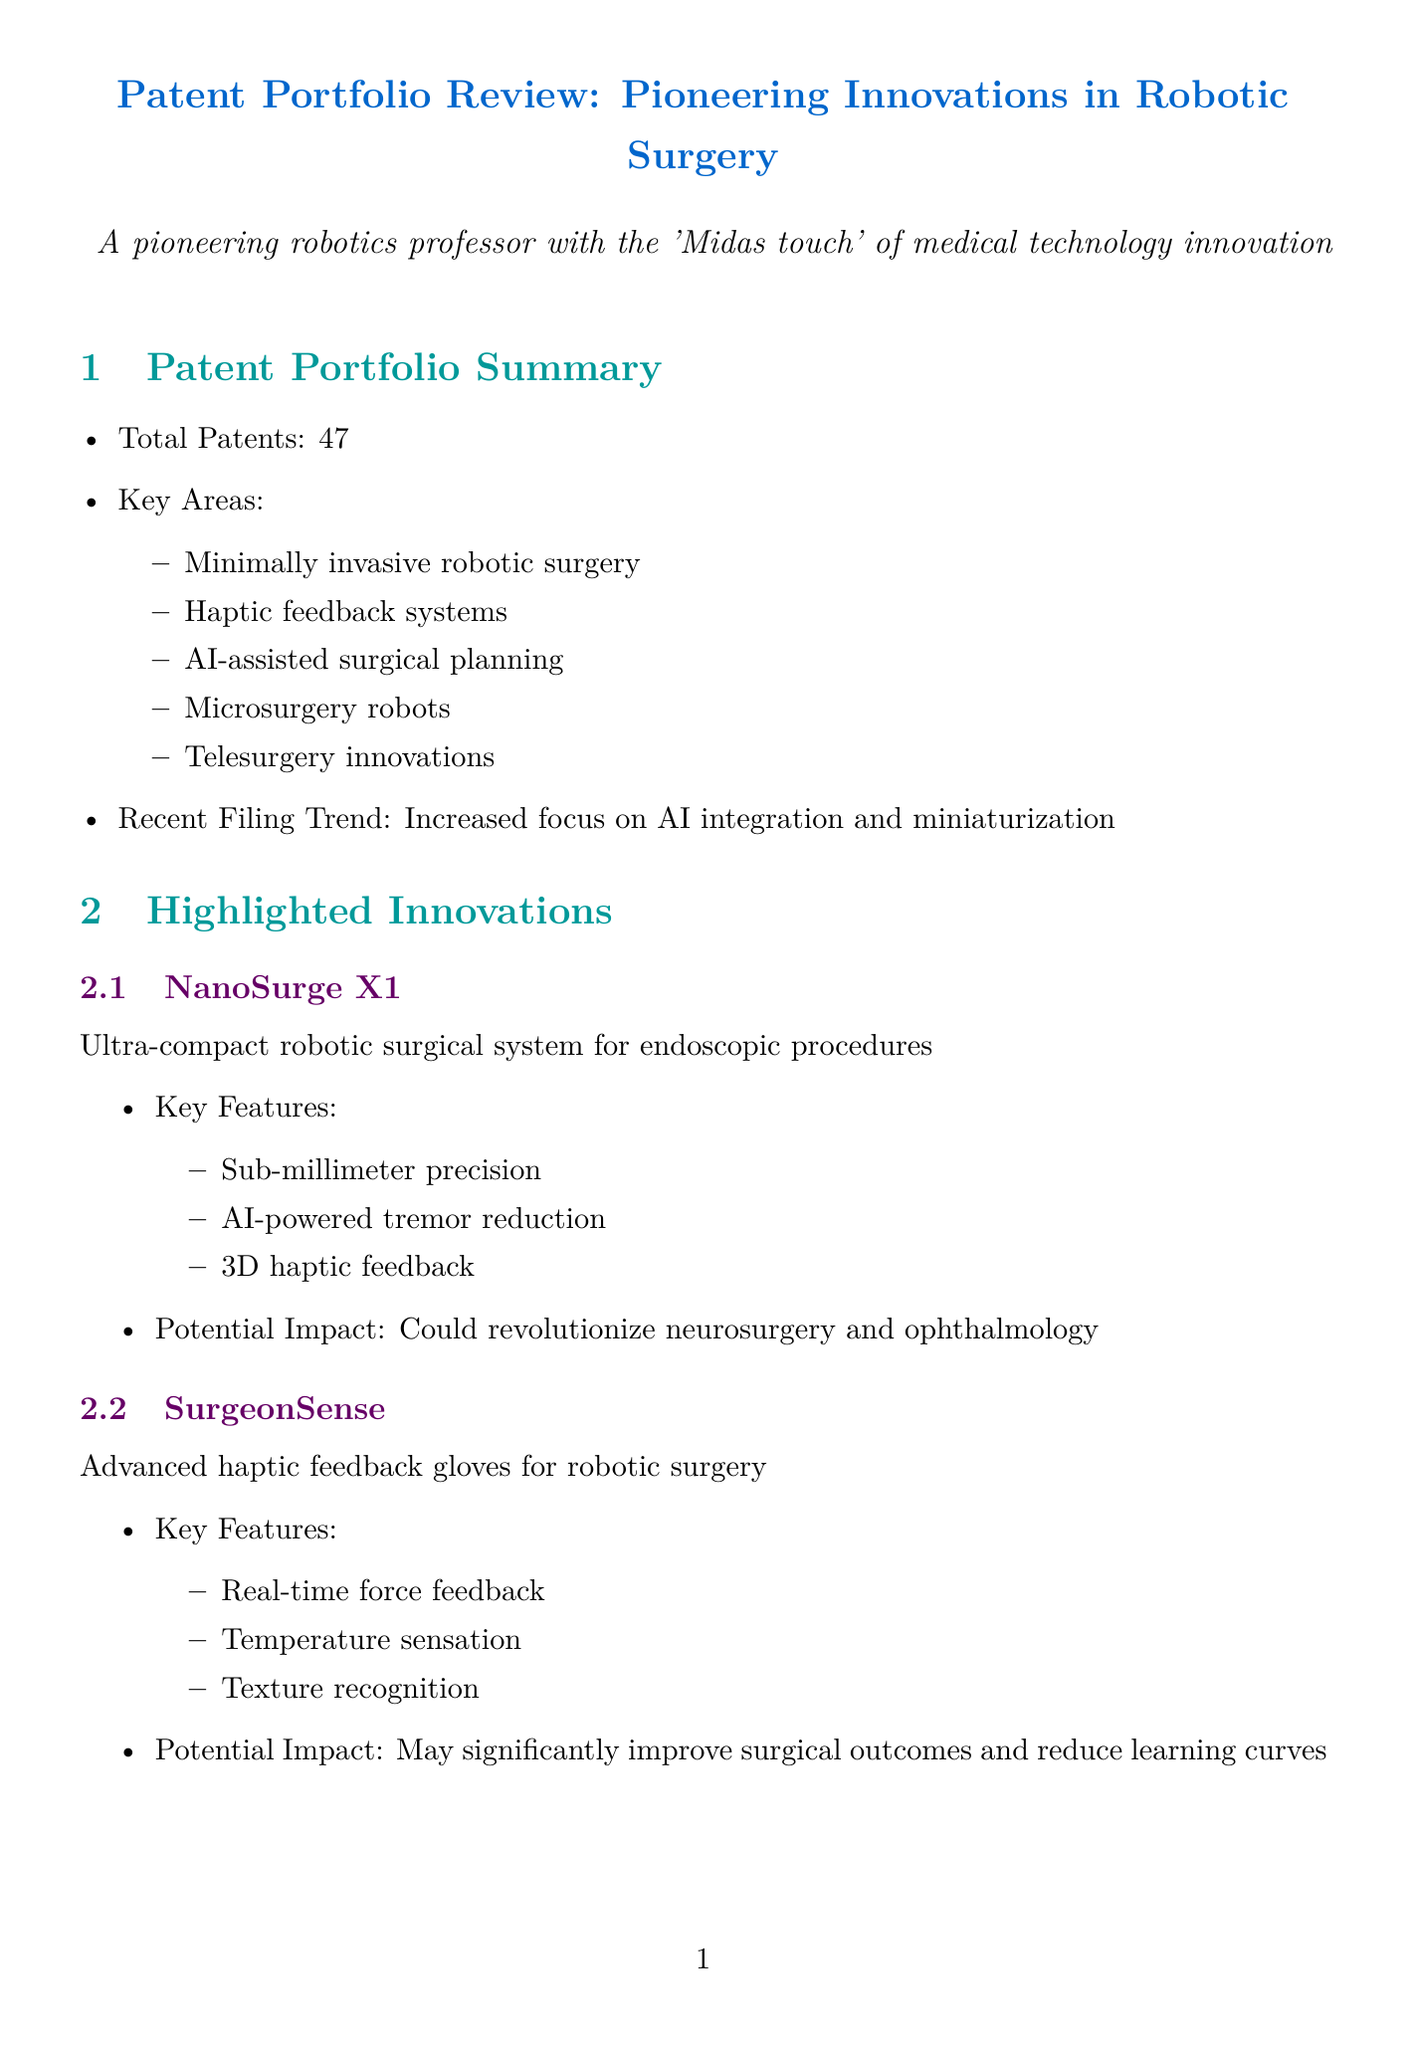what is the total number of patents in the portfolio? The total number of patents is explicitly stated in the summary section of the document.
Answer: 47 what is the potential impact of NanoSurge X1? The document specifies the potential impact of NanoSurge X1 in the highlighted innovations section.
Answer: Could revolutionize neurosurgery and ophthalmology what is the current market size for minimally invasive robotic surgery? The current market size is detailed in the market analysis section of the document.
Answer: $5.3 billion who is collaborating with Johns Hopkins University? The collaborations section lists the partners for various projects, including this one.
Answer: Johns Hopkins University what are the key drivers for market growth? The key drivers are listed in the market analysis part of the document.
Answer: Aging population, Increasing prevalence of chronic diseases, Technological advancements in robotics and AI what significant award was received in 2022? The awards section provides a list of recognitions and the year they were attained.
Answer: IEEE Robotics and Automation Award what is the projected job creation in the healthcare robotics sector by 2025? The document outlines anticipated job creation in the economic impact projection section.
Answer: Estimated 15,000 new jobs what innovation focuses on real-time force feedback? The highlighted innovations section names specific innovations and their features.
Answer: SurgeonSense what future research direction involves advanced technology for surgical capabilities? One of the future research directions mentions a new technological integration for surgery.
Answer: Integration of 5G technology for improved telesurgery capabilities 